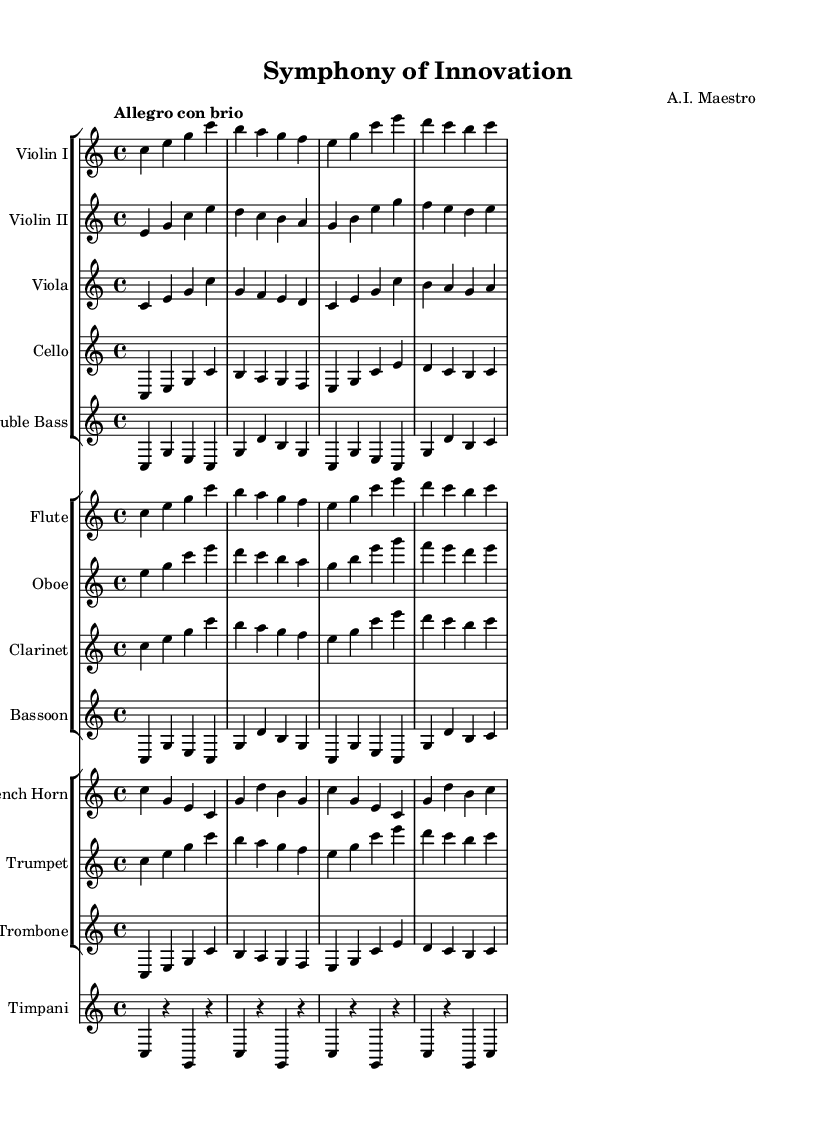What is the key signature of this music? The key signature is C major, which has no sharps or flats indicated at the beginning of the staff.
Answer: C major What is the time signature of this music? The time signature is indicated as 4/4, meaning there are four beats in a measure and a quarter note gets one beat.
Answer: 4/4 What is the tempo marking for this piece? The tempo marking shows "Allegro con brio," indicating a fast and lively pace.
Answer: Allegro con brio How many measures are in the violin part? Counting through the notes provided for the violin, there are a total of four measures indicated by the grouping of notes and bars.
Answer: 4 What instruments are included in the brass section? The sheet music lists the French horn, trumpet, and trombone specifically under the brass section.
Answer: French horn, trumpet, trombone Which instrument plays the opening melody? The opening melody is first introduced in the Violin I part with a series of ascending notes.
Answer: Violin I Explain the use of dynamics in the piece. While the sheet music does not explicitly indicate dynamics, the tempo marking "Allegro con brio" suggests a lively and energetic performance, which typically implies a forte (loud) dynamic. Additionally, the instrumentation leads to a rich and full sound, enhancing the sense of innovation.
Answer: Allegro con brio suggests lively dynamics 